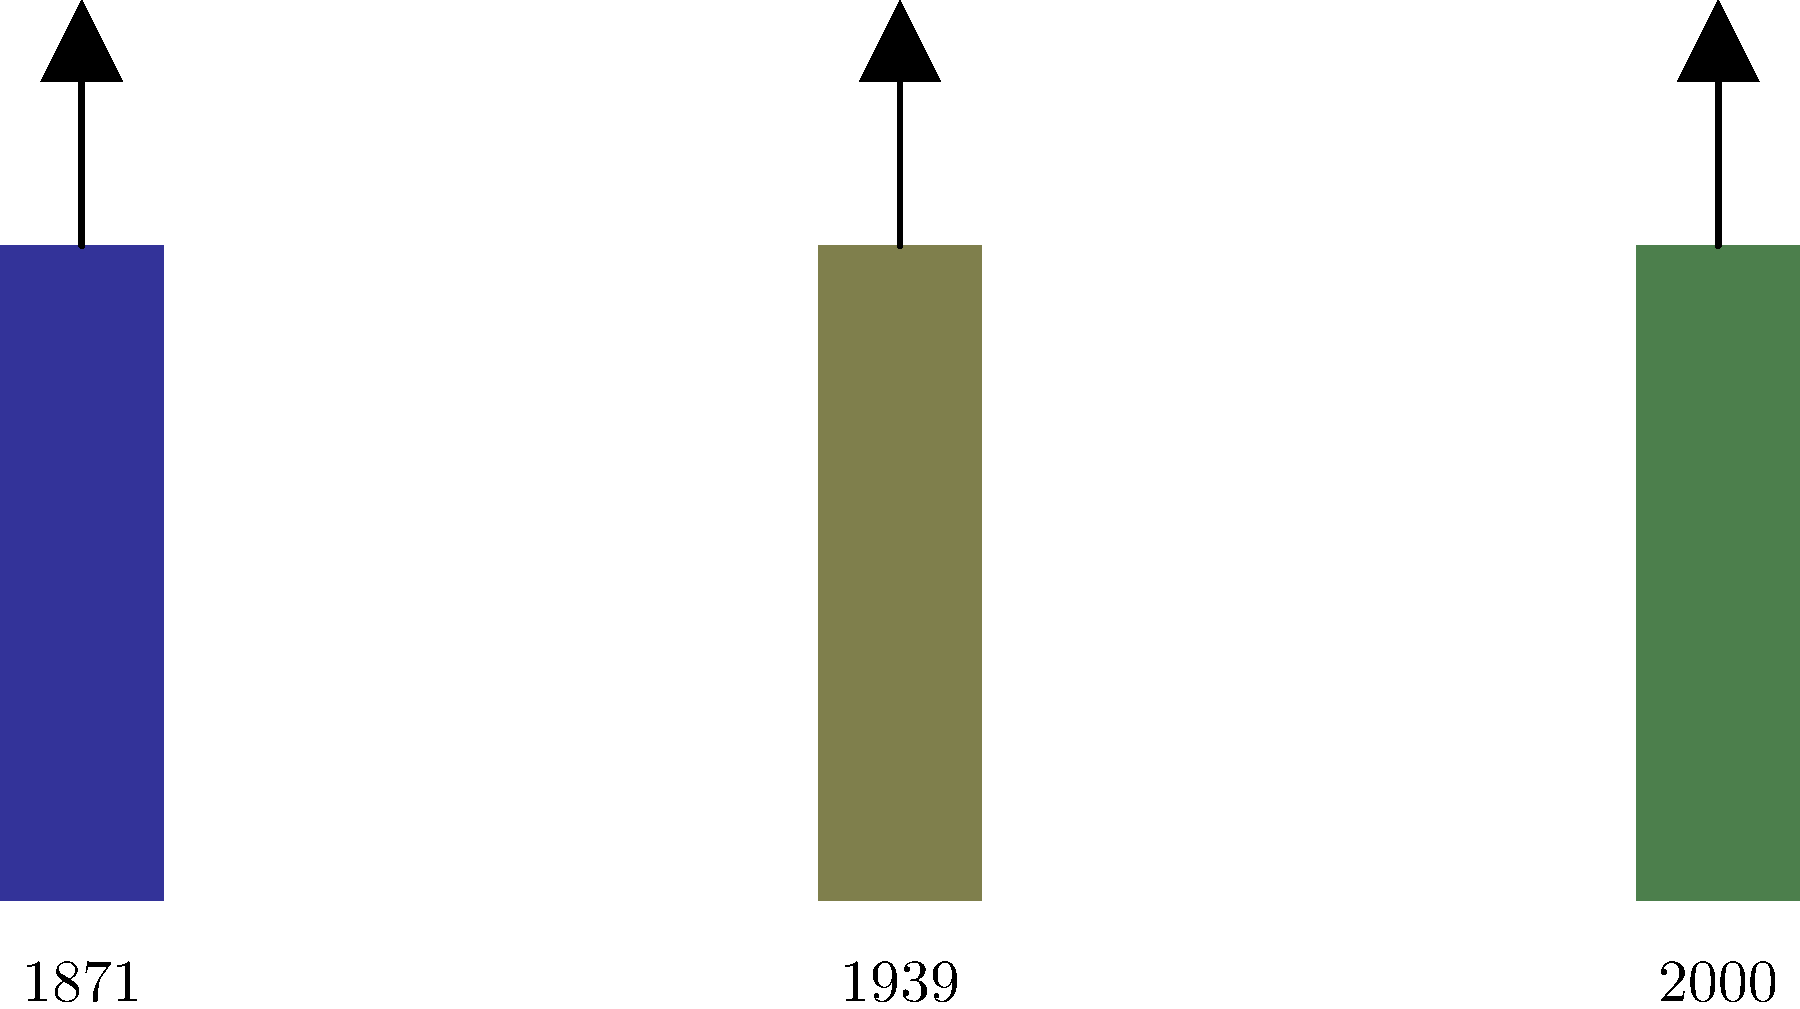Based on the evolution of German military uniforms shown in the illustration, which historical event likely influenced the significant color change between the first and second uniforms? To answer this question, we need to analyze the visual information provided and connect it to our knowledge of German history:

1. The first uniform (1871) is dark blue, typical of the Prussian and early German Empire military.
2. The second uniform (1939) shows a significant shift to a greenish-brown color.
3. The year 1939 coincides with the beginning of World War II.
4. The color change reflects a shift towards more practical, camouflage-oriented uniforms.
5. This shift was largely influenced by the experiences of World War I (1914-1918), where traditional bright uniforms proved disadvantageous in modern warfare.
6. The lessons learned from WWI led to the development of field gray (Feldgrau) uniforms, which offered better camouflage.

Therefore, World War I was the historical event that most likely influenced this significant color change in German military uniforms.
Answer: World War I 